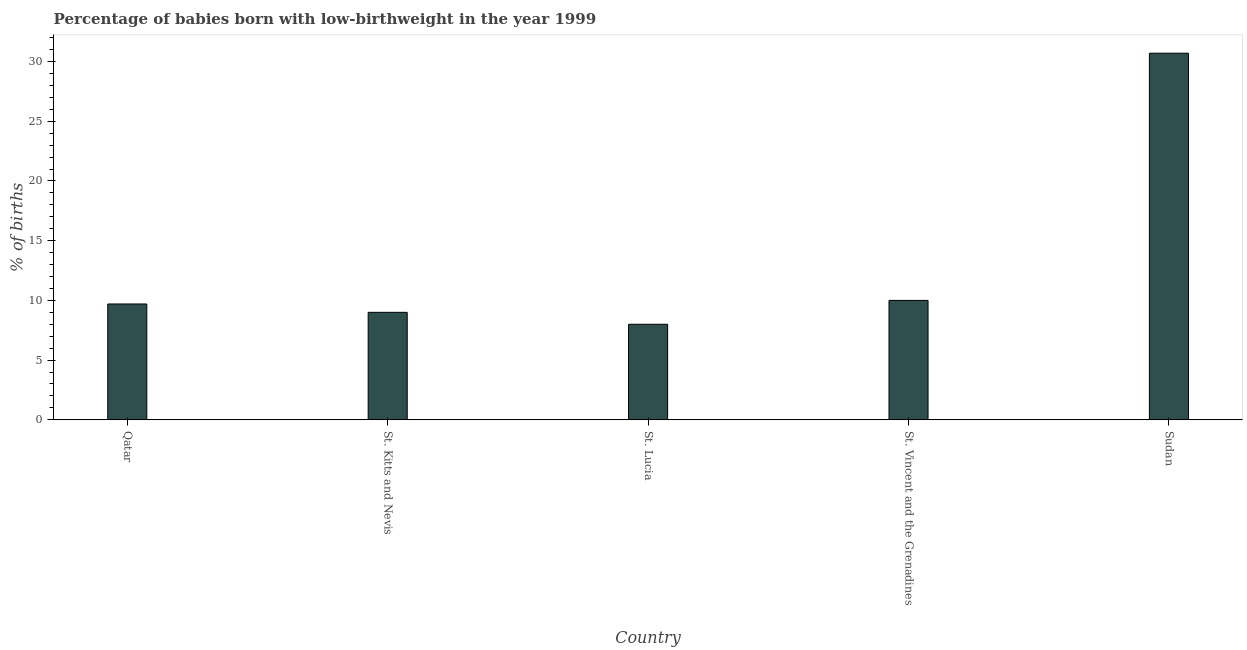Does the graph contain grids?
Keep it short and to the point. No. What is the title of the graph?
Your answer should be compact. Percentage of babies born with low-birthweight in the year 1999. What is the label or title of the X-axis?
Offer a very short reply. Country. What is the label or title of the Y-axis?
Offer a very short reply. % of births. Across all countries, what is the maximum percentage of babies who were born with low-birthweight?
Offer a terse response. 30.7. Across all countries, what is the minimum percentage of babies who were born with low-birthweight?
Make the answer very short. 8. In which country was the percentage of babies who were born with low-birthweight maximum?
Offer a terse response. Sudan. In which country was the percentage of babies who were born with low-birthweight minimum?
Ensure brevity in your answer.  St. Lucia. What is the sum of the percentage of babies who were born with low-birthweight?
Ensure brevity in your answer.  67.4. What is the difference between the percentage of babies who were born with low-birthweight in Qatar and St. Kitts and Nevis?
Give a very brief answer. 0.7. What is the average percentage of babies who were born with low-birthweight per country?
Your response must be concise. 13.48. What is the ratio of the percentage of babies who were born with low-birthweight in Qatar to that in St. Vincent and the Grenadines?
Offer a very short reply. 0.97. Is the percentage of babies who were born with low-birthweight in St. Kitts and Nevis less than that in Sudan?
Provide a succinct answer. Yes. What is the difference between the highest and the second highest percentage of babies who were born with low-birthweight?
Provide a short and direct response. 20.7. Is the sum of the percentage of babies who were born with low-birthweight in Qatar and Sudan greater than the maximum percentage of babies who were born with low-birthweight across all countries?
Your response must be concise. Yes. What is the difference between the highest and the lowest percentage of babies who were born with low-birthweight?
Your answer should be compact. 22.7. In how many countries, is the percentage of babies who were born with low-birthweight greater than the average percentage of babies who were born with low-birthweight taken over all countries?
Give a very brief answer. 1. How many bars are there?
Your answer should be very brief. 5. What is the % of births in St. Kitts and Nevis?
Offer a terse response. 9. What is the % of births of St. Vincent and the Grenadines?
Offer a very short reply. 10. What is the % of births in Sudan?
Keep it short and to the point. 30.7. What is the difference between the % of births in Qatar and St. Kitts and Nevis?
Give a very brief answer. 0.7. What is the difference between the % of births in Qatar and St. Lucia?
Offer a terse response. 1.7. What is the difference between the % of births in Qatar and St. Vincent and the Grenadines?
Your answer should be very brief. -0.3. What is the difference between the % of births in St. Kitts and Nevis and St. Lucia?
Your answer should be very brief. 1. What is the difference between the % of births in St. Kitts and Nevis and Sudan?
Offer a terse response. -21.7. What is the difference between the % of births in St. Lucia and St. Vincent and the Grenadines?
Provide a short and direct response. -2. What is the difference between the % of births in St. Lucia and Sudan?
Your response must be concise. -22.7. What is the difference between the % of births in St. Vincent and the Grenadines and Sudan?
Make the answer very short. -20.7. What is the ratio of the % of births in Qatar to that in St. Kitts and Nevis?
Your answer should be compact. 1.08. What is the ratio of the % of births in Qatar to that in St. Lucia?
Your answer should be very brief. 1.21. What is the ratio of the % of births in Qatar to that in Sudan?
Provide a succinct answer. 0.32. What is the ratio of the % of births in St. Kitts and Nevis to that in St. Lucia?
Your response must be concise. 1.12. What is the ratio of the % of births in St. Kitts and Nevis to that in St. Vincent and the Grenadines?
Offer a very short reply. 0.9. What is the ratio of the % of births in St. Kitts and Nevis to that in Sudan?
Your answer should be very brief. 0.29. What is the ratio of the % of births in St. Lucia to that in St. Vincent and the Grenadines?
Give a very brief answer. 0.8. What is the ratio of the % of births in St. Lucia to that in Sudan?
Offer a terse response. 0.26. What is the ratio of the % of births in St. Vincent and the Grenadines to that in Sudan?
Provide a short and direct response. 0.33. 